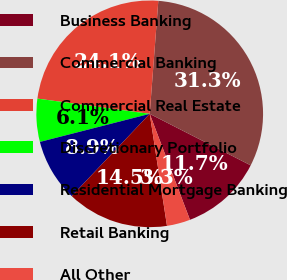Convert chart to OTSL. <chart><loc_0><loc_0><loc_500><loc_500><pie_chart><fcel>Business Banking<fcel>Commercial Banking<fcel>Commercial Real Estate<fcel>Discretionary Portfolio<fcel>Residential Mortgage Banking<fcel>Retail Banking<fcel>All Other<nl><fcel>11.72%<fcel>31.29%<fcel>24.06%<fcel>6.13%<fcel>8.93%<fcel>14.52%<fcel>3.34%<nl></chart> 